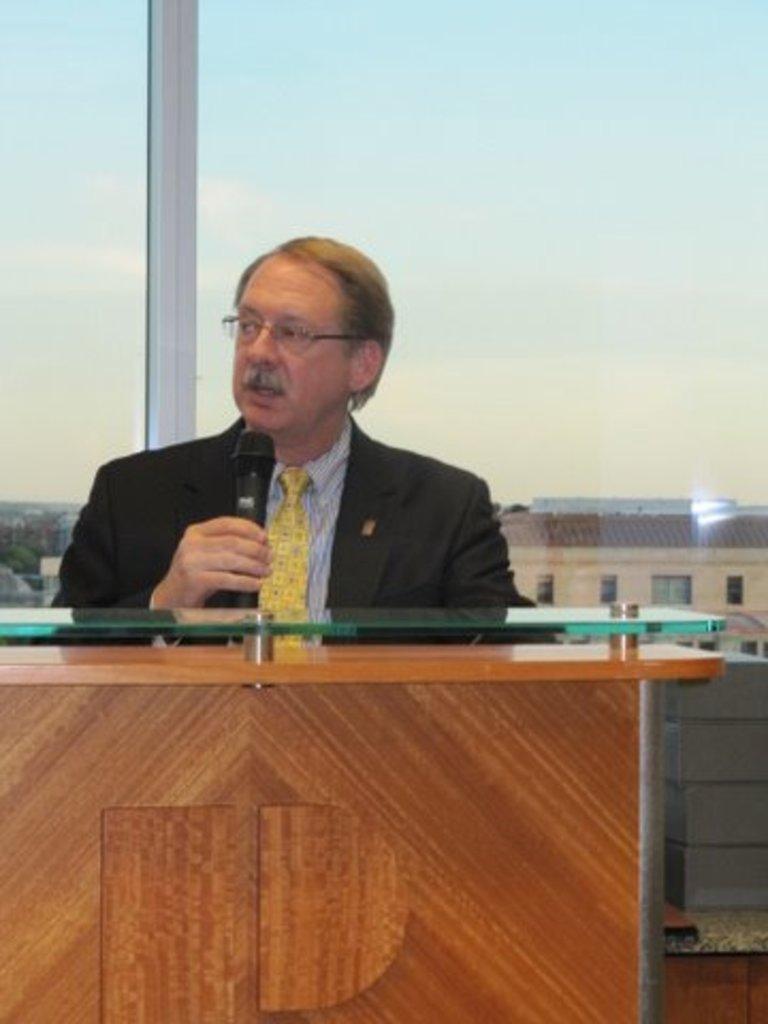Please provide a concise description of this image. In the foreground of the picture there is a man holding a mic and speaking, in front of him there is a desk. In the background there is a glass window, outside the window there are trees, house and the aerial view of the city. Sky is clear. 